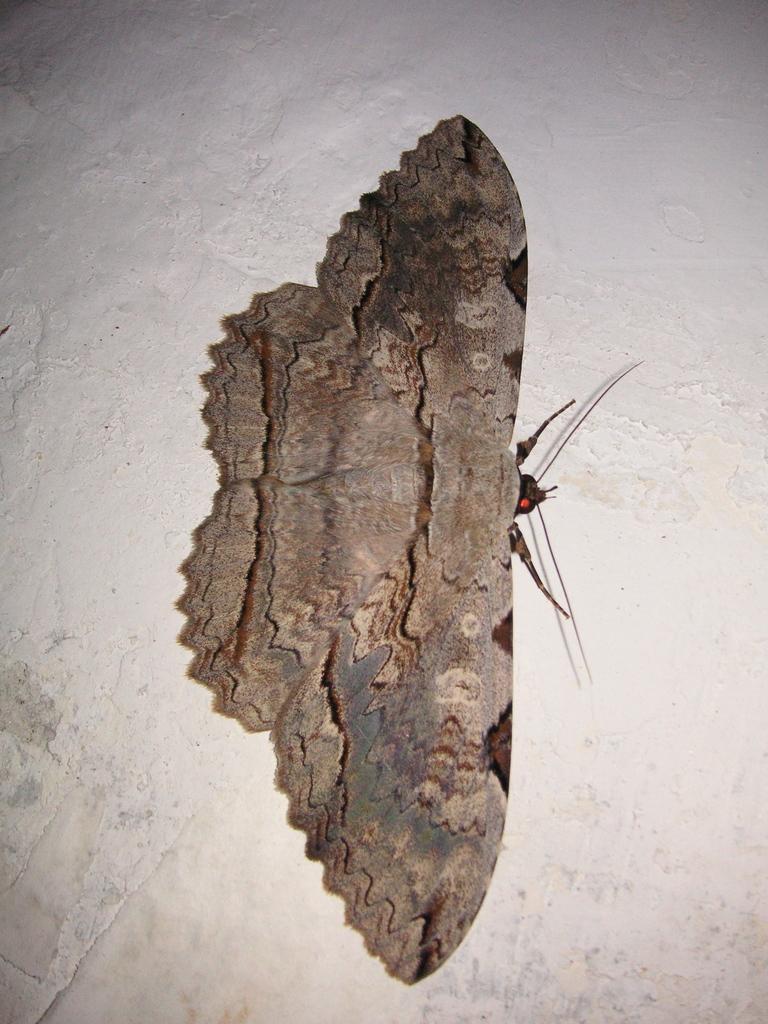Describe this image in one or two sentences. In this picture I can see there is an insect and it has wings, legs, head and body. In the backdrop there is a wall. 